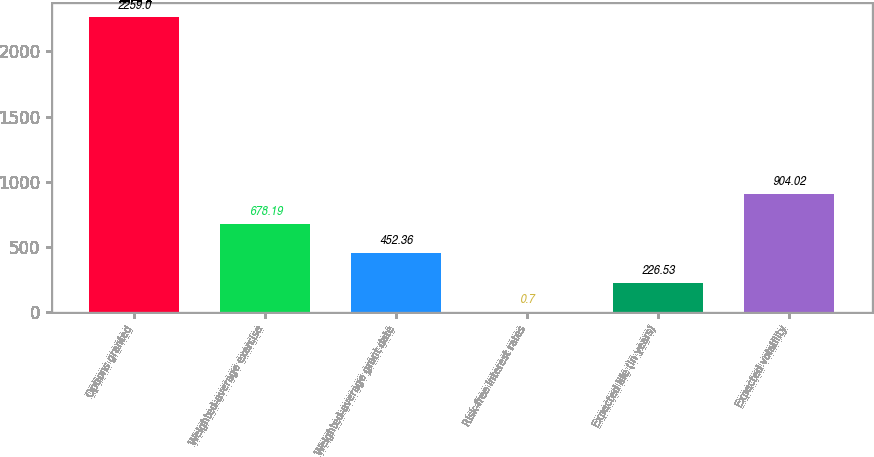Convert chart. <chart><loc_0><loc_0><loc_500><loc_500><bar_chart><fcel>Options granted<fcel>Weighted-average exercise<fcel>Weighted-average grant date<fcel>Risk-free interest rates<fcel>Expected life (in years)<fcel>Expected volatility<nl><fcel>2259<fcel>678.19<fcel>452.36<fcel>0.7<fcel>226.53<fcel>904.02<nl></chart> 